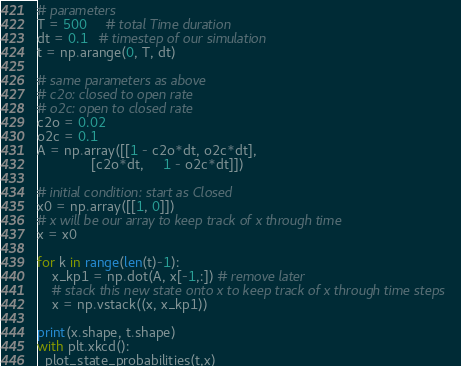<code> <loc_0><loc_0><loc_500><loc_500><_Python_>
# parameters
T = 500     # total Time duration
dt = 0.1   # timestep of our simulation
t = np.arange(0, T, dt)

# same parameters as above
# c2o: closed to open rate
# o2c: open to closed rate
c2o = 0.02
o2c = 0.1
A = np.array([[1 - c2o*dt, o2c*dt],
              [c2o*dt,     1 - o2c*dt]])

# initial condition: start as Closed
x0 = np.array([[1, 0]]) 
# x will be our array to keep track of x through time
x = x0

for k in range(len(t)-1):
    x_kp1 = np.dot(A, x[-1,:]) # remove later
    # stack this new state onto x to keep track of x through time steps
    x = np.vstack((x, x_kp1))

print(x.shape, t.shape)
with plt.xkcd():
  plot_state_probabilities(t,x)</code> 